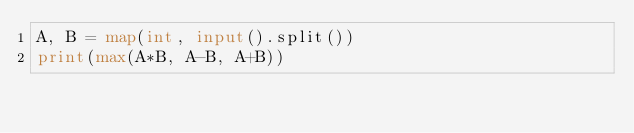<code> <loc_0><loc_0><loc_500><loc_500><_Python_>A, B = map(int, input().split())
print(max(A*B, A-B, A+B))</code> 